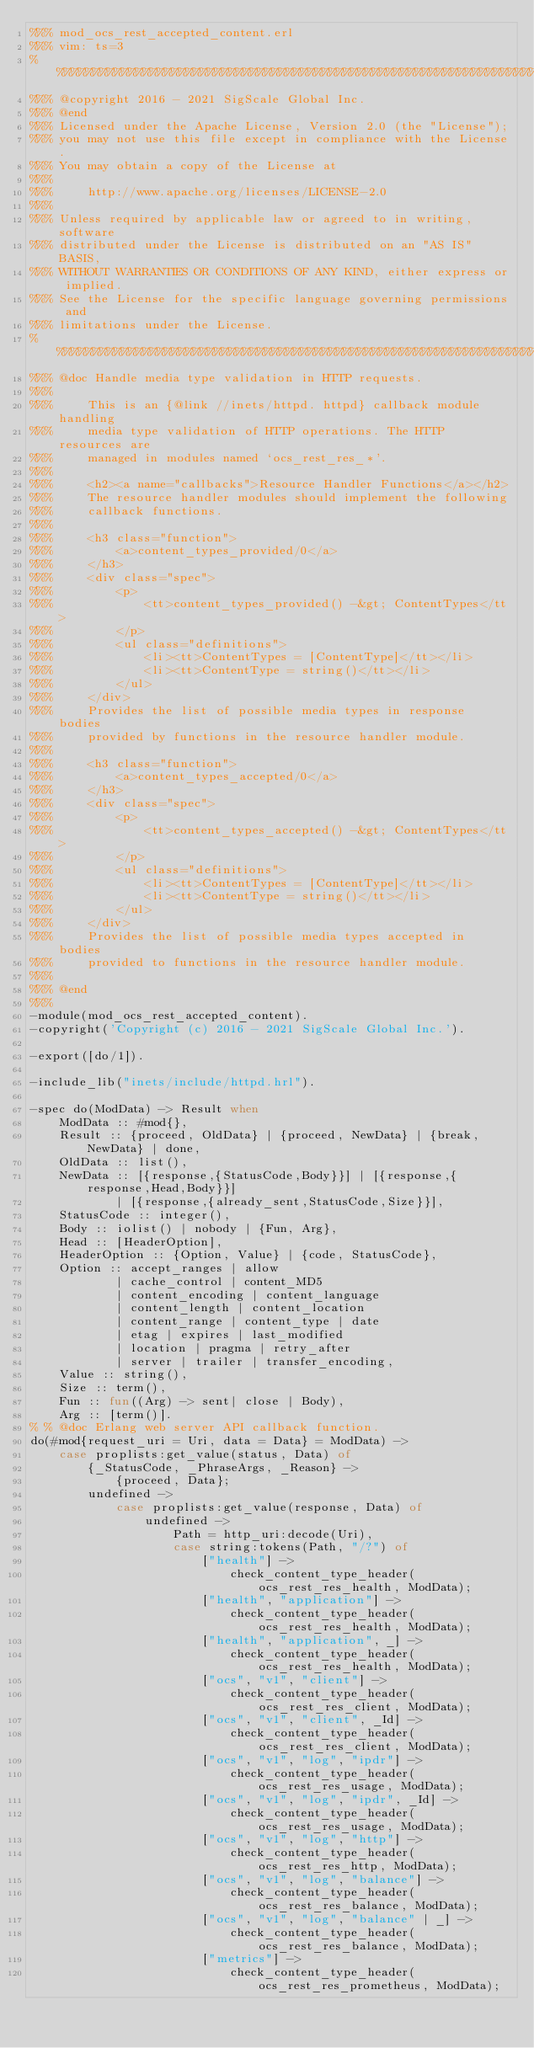<code> <loc_0><loc_0><loc_500><loc_500><_Erlang_>%%% mod_ocs_rest_accepted_content.erl
%%% vim: ts=3
%%%%%%%%%%%%%%%%%%%%%%%%%%%%%%%%%%%%%%%%%%%%%%%%%%%%%%%%%%%%%%%%%%%%%%%%%%%%%
%%% @copyright 2016 - 2021 SigScale Global Inc.
%%% @end
%%% Licensed under the Apache License, Version 2.0 (the "License");
%%% you may not use this file except in compliance with the License.
%%% You may obtain a copy of the License at
%%%
%%%     http://www.apache.org/licenses/LICENSE-2.0
%%%
%%% Unless required by applicable law or agreed to in writing, software
%%% distributed under the License is distributed on an "AS IS" BASIS,
%%% WITHOUT WARRANTIES OR CONDITIONS OF ANY KIND, either express or implied.
%%% See the License for the specific language governing permissions and
%%% limitations under the License.
%%%%%%%%%%%%%%%%%%%%%%%%%%%%%%%%%%%%%%%%%%%%%%%%%%%%%%%%%%%%%%%%%%%%%%%%%%%%%
%%% @doc Handle media type validation in HTTP requests.
%%%
%%% 	This is an {@link //inets/httpd. httpd} callback module handling
%%% 	media type validation of HTTP operations. The HTTP resources are
%%% 	managed in modules named `ocs_rest_res_*'.
%%%
%%% 	<h2><a name="callbacks">Resource Handler Functions</a></h2>
%%% 	The resource handler modules should implement the following
%%% 	callback functions.
%%%
%%% 	<h3 class="function">
%%% 		<a>content_types_provided/0</a>
%%% 	</h3>
%%% 	<div class="spec">
%%% 		<p>
%%% 			<tt>content_types_provided() -&gt; ContentTypes</tt>
%%% 		</p>
%%% 		<ul class="definitions">
%%% 			<li><tt>ContentTypes = [ContentType]</tt></li>
%%% 			<li><tt>ContentType = string()</tt></li>
%%% 		</ul>
%%% 	</div>
%%% 	Provides the list of possible media types in response bodies
%%% 	provided by functions in the resource handler module.
%%%
%%% 	<h3 class="function">
%%% 		<a>content_types_accepted/0</a>
%%% 	</h3>
%%% 	<div class="spec">
%%% 		<p>
%%% 			<tt>content_types_accepted() -&gt; ContentTypes</tt>
%%% 		</p>
%%% 		<ul class="definitions">
%%% 			<li><tt>ContentTypes = [ContentType]</tt></li>
%%% 			<li><tt>ContentType = string()</tt></li>
%%% 		</ul>
%%% 	</div>
%%% 	Provides the list of possible media types accepted in bodies
%%% 	provided to functions in the resource handler module.
%%%
%%% @end
%%%
-module(mod_ocs_rest_accepted_content).
-copyright('Copyright (c) 2016 - 2021 SigScale Global Inc.').

-export([do/1]).

-include_lib("inets/include/httpd.hrl").

-spec do(ModData) -> Result when
	ModData :: #mod{},
	Result :: {proceed, OldData} | {proceed, NewData} | {break, NewData} | done,
	OldData :: list(),
	NewData :: [{response,{StatusCode,Body}}] | [{response,{response,Head,Body}}]
			| [{response,{already_sent,StatusCode,Size}}],
	StatusCode :: integer(),
	Body :: iolist() | nobody | {Fun, Arg},
	Head :: [HeaderOption],
	HeaderOption :: {Option, Value} | {code, StatusCode},
	Option :: accept_ranges | allow
			| cache_control | content_MD5
			| content_encoding | content_language
			| content_length | content_location
			| content_range | content_type | date
			| etag | expires | last_modified
			| location | pragma | retry_after
			| server | trailer | transfer_encoding,
	Value :: string(),
	Size :: term(),
	Fun :: fun((Arg) -> sent| close | Body),
	Arg :: [term()].
% % @doc Erlang web server API callback function.
do(#mod{request_uri = Uri, data = Data} = ModData) ->
	case proplists:get_value(status, Data) of
		{_StatusCode, _PhraseArgs, _Reason} ->
			{proceed, Data};
		undefined ->
			case proplists:get_value(response, Data) of
				undefined ->
					Path = http_uri:decode(Uri),
					case string:tokens(Path, "/?") of
						["health"] ->
							check_content_type_header(ocs_rest_res_health, ModData);
						["health", "application"] ->
							check_content_type_header(ocs_rest_res_health, ModData);
						["health", "application", _] ->
							check_content_type_header(ocs_rest_res_health, ModData);
						["ocs", "v1", "client"] ->
							check_content_type_header(ocs_rest_res_client, ModData);
						["ocs", "v1", "client", _Id] ->
							check_content_type_header(ocs_rest_res_client, ModData);
						["ocs", "v1", "log", "ipdr"] ->
							check_content_type_header(ocs_rest_res_usage, ModData);
						["ocs", "v1", "log", "ipdr", _Id] ->
							check_content_type_header(ocs_rest_res_usage, ModData);
						["ocs", "v1", "log", "http"] ->
							check_content_type_header(ocs_rest_res_http, ModData);
						["ocs", "v1", "log", "balance"] ->
							check_content_type_header(ocs_rest_res_balance, ModData);
						["ocs", "v1", "log", "balance" | _] ->
							check_content_type_header(ocs_rest_res_balance, ModData);
						["metrics"] ->
							check_content_type_header(ocs_rest_res_prometheus, ModData);</code> 